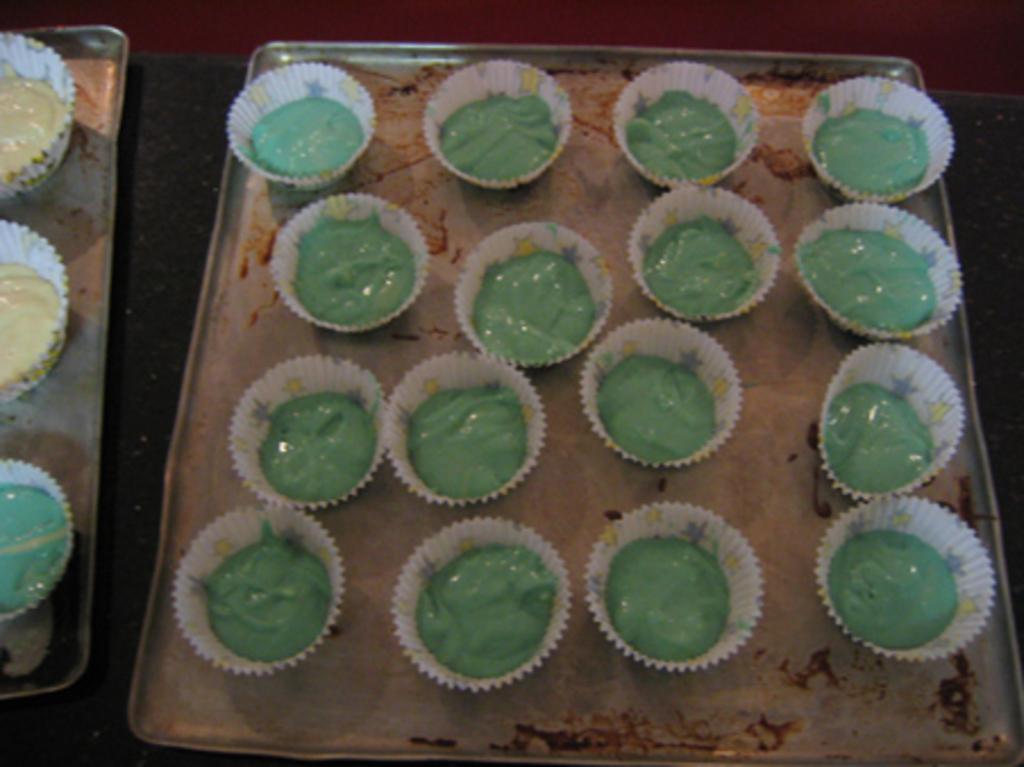Describe this image in one or two sentences. In this image there is battery in paper cups ,on the silver trays. 